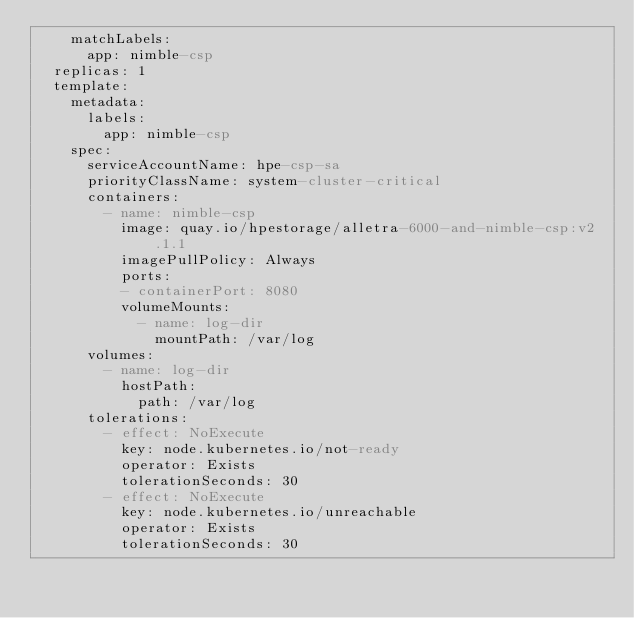<code> <loc_0><loc_0><loc_500><loc_500><_YAML_>    matchLabels:
      app: nimble-csp
  replicas: 1
  template:
    metadata:
      labels:
        app: nimble-csp
    spec:
      serviceAccountName: hpe-csp-sa
      priorityClassName: system-cluster-critical
      containers:
        - name: nimble-csp
          image: quay.io/hpestorage/alletra-6000-and-nimble-csp:v2.1.1
          imagePullPolicy: Always
          ports:
          - containerPort: 8080
          volumeMounts:
            - name: log-dir
              mountPath: /var/log
      volumes:
        - name: log-dir
          hostPath:
            path: /var/log
      tolerations:
        - effect: NoExecute
          key: node.kubernetes.io/not-ready
          operator: Exists
          tolerationSeconds: 30
        - effect: NoExecute
          key: node.kubernetes.io/unreachable
          operator: Exists
          tolerationSeconds: 30
</code> 